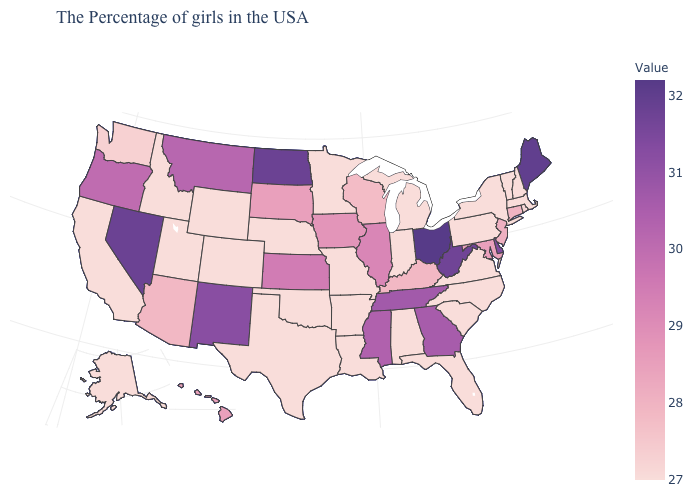Does Connecticut have the highest value in the USA?
Give a very brief answer. No. Does South Carolina have the lowest value in the USA?
Answer briefly. Yes. Among the states that border Georgia , does South Carolina have the lowest value?
Write a very short answer. Yes. Does the map have missing data?
Be succinct. No. Among the states that border New York , which have the lowest value?
Keep it brief. Massachusetts, Vermont, Pennsylvania. 